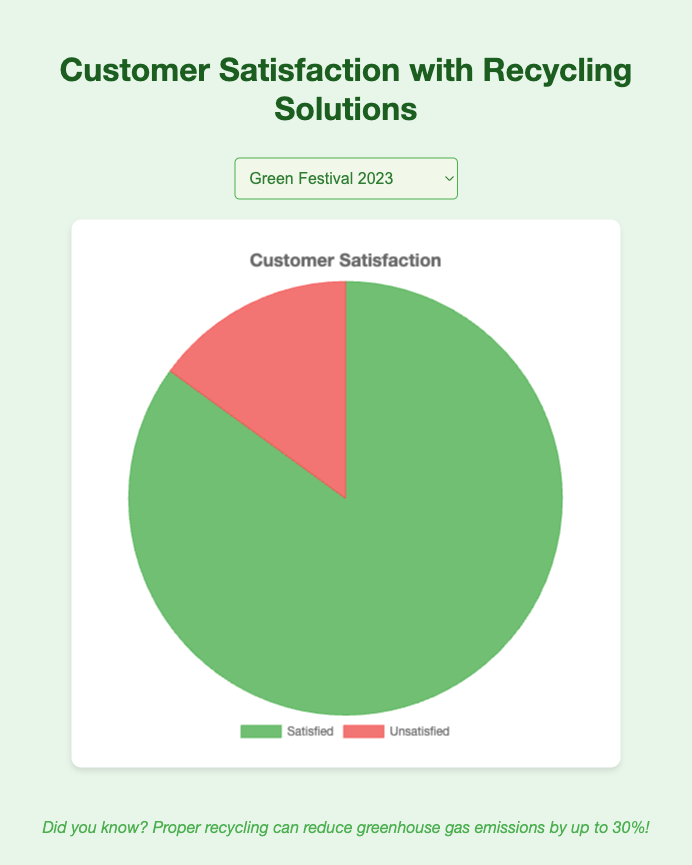Which event has the highest percentage of satisfied customers? The Renewable Expo 2023 has the highest satified customers percentage of 90%. This can be interpreted by quickly scanning the data points for the percentage values and identifying the highest one.
Answer: Renewable Expo 2023 Which event has more satisfied customers, Green Festival 2023 or Eco Summit 2023? To compare Green Festival 2023 and Eco Summit 2023, the percentages of satisfied customers are 85% and 80%, respectively. Thus, Green Festival 2023 has a higher satisfaction rate.
Answer: Green Festival 2023 What is the difference between the satisfied customer percentages of Renewable Expo 2023 and Sustainability Conference? The satisfied customer percentages are 90% for Renewable Expo 2023 and 82 % for Sustainability Conference. The difference is calculated as 90% - 82% = 8%.
Answer: 8% What is the average percentage of satisfied customers across all four events? To find the average: sum the percentages (85% + 80% + 90% + 82%) = 337% and divide by the number of events (4). The average is 337% / 4 = 84.25%.
Answer: 84.25% Which event has the highest percentage of unsatisfied customers? The Eco Summit 2023 has the highest unsatisfied customer percentage of 20%. The highest value can be inferred from the presented data points.
Answer: Eco Summit 2023 What is the difference in satisfaction between the event with the highest satisfied customer percentage and the event with the lowest? The Renewable Expo 2023 has the highest satisfaction rate at 90%, while the Eco Summit 2023 has the lowest at 80%. The difference is 90% - 80% = 10%.
Answer: 10% How do satisfied and unsatisfied customer percentages compare visually in the chart for each event? The satisfied customer portions of the pie are significantly larger and shown in green, while the unsatisfied portions are smaller and shown in red. This visual comparison makes it easy to distinguish the higher satisfaction rates visually.
Answer: Green is larger What percentage of customers are unsatisfied with the Sustainability Conference? According to the data, the unsatisfied customer percentage for the Sustainability Conference is 18%. This value can be directly read from the data provided.
Answer: 18% Is the unsatisfied customer percentage for Renewable Expo 2023 smaller than the highest satisfied customer percentage overall? The unsatisfied customer percentage for Renewable Expo 2023 is 10%, while the highest satisfied percentage is 90% for the same event. Comparatively, 10% is indeed smaller than 90%.
Answer: Yes, smaller If you combine the unsatisfied percentages of Eco Summit 2023 and Sustainability Conference, what is the value? Adding the unsatisfied percentages of both events: Eco Summit 2023 (20%) + Sustainability Conference (18%) = 38%.
Answer: 38% 